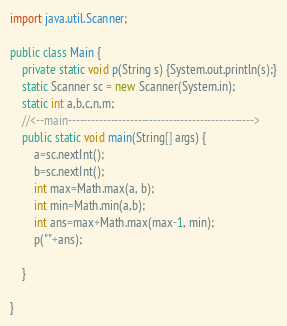<code> <loc_0><loc_0><loc_500><loc_500><_Java_>import java.util.Scanner;

public class Main {
	private static void p(String s) {System.out.println(s);}
	static Scanner sc = new Scanner(System.in);
	static int a,b,c,n,m;
	//<--main------------------------------------------------>
	public static void main(String[] args) {
		a=sc.nextInt();
		b=sc.nextInt();
		int max=Math.max(a, b);
		int min=Math.min(a,b);
		int ans=max+Math.max(max-1, min);
		p(""+ans);

	}

}
</code> 